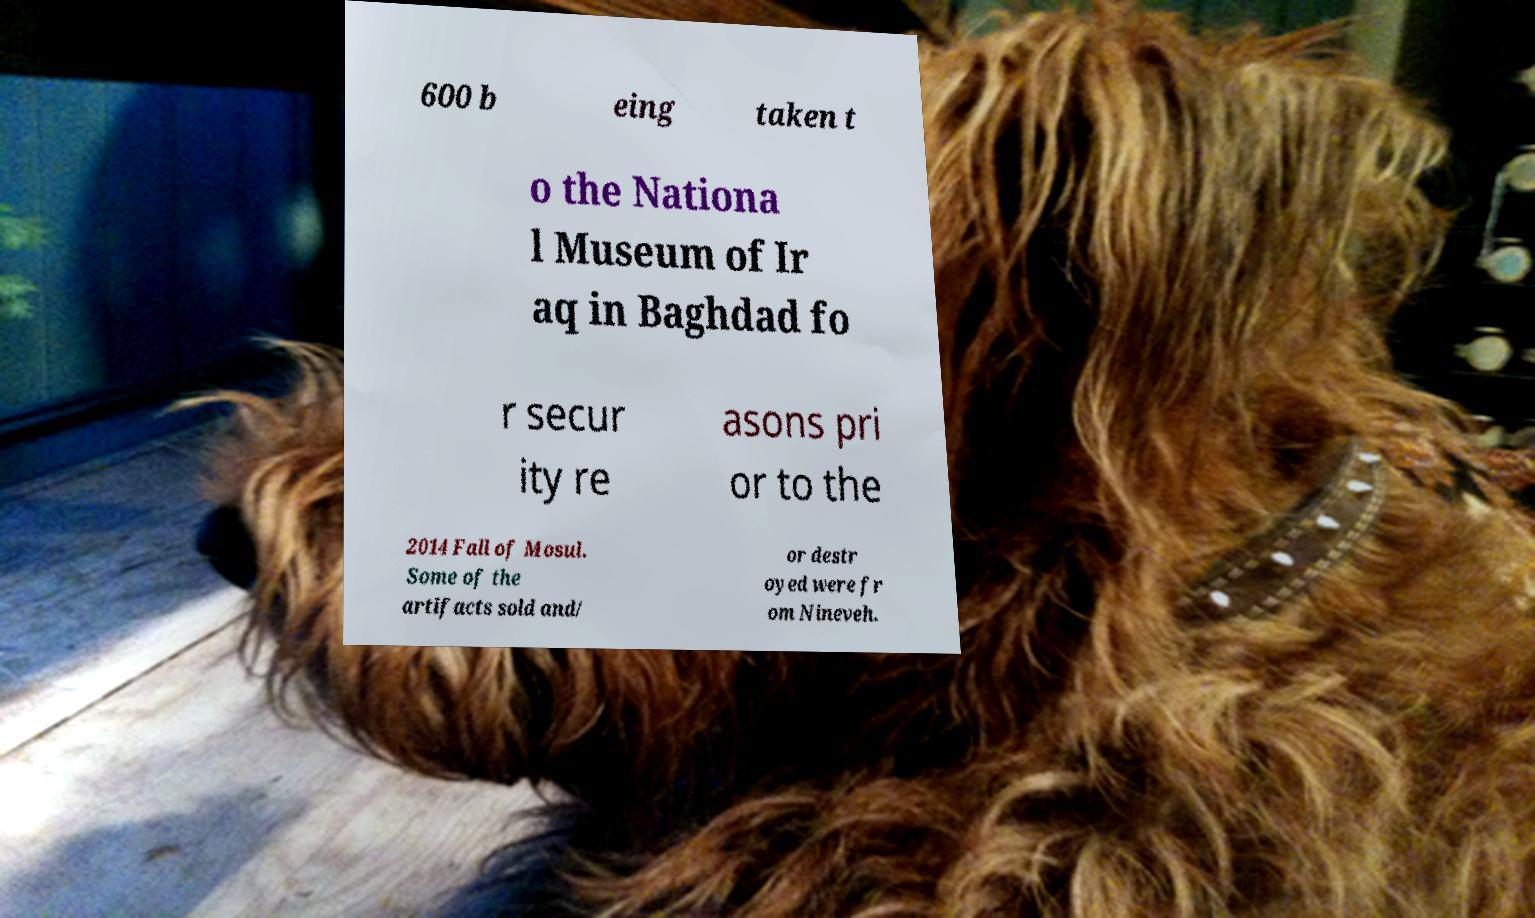Could you extract and type out the text from this image? 600 b eing taken t o the Nationa l Museum of Ir aq in Baghdad fo r secur ity re asons pri or to the 2014 Fall of Mosul. Some of the artifacts sold and/ or destr oyed were fr om Nineveh. 